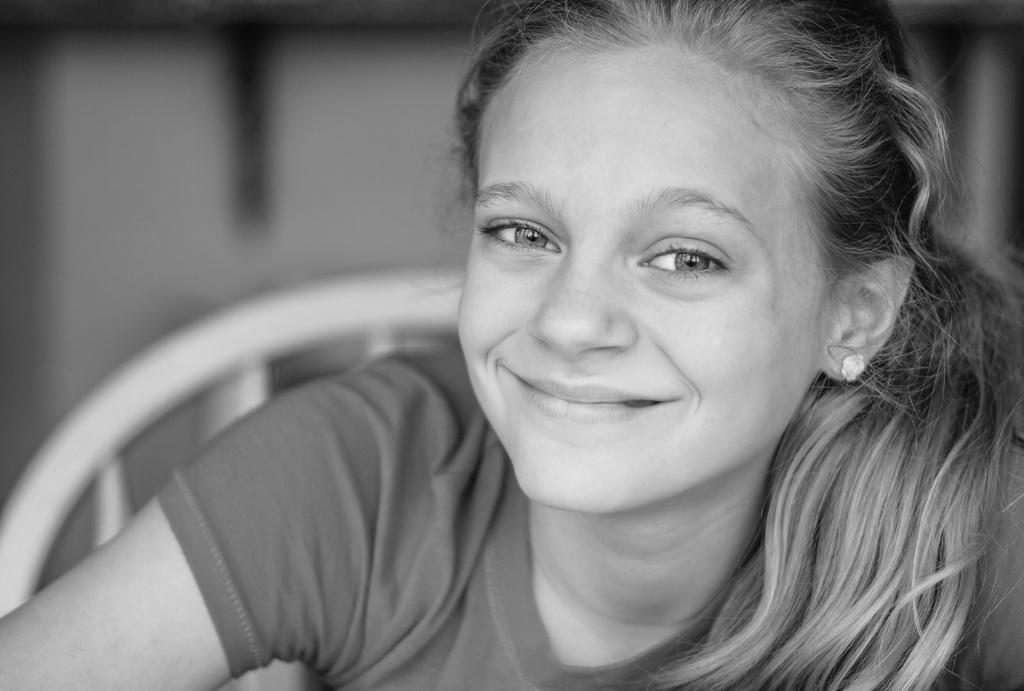Please provide a concise description of this image. In this image, in the foreground I can see a person sitting on the chair and in the background I can see the blur. 